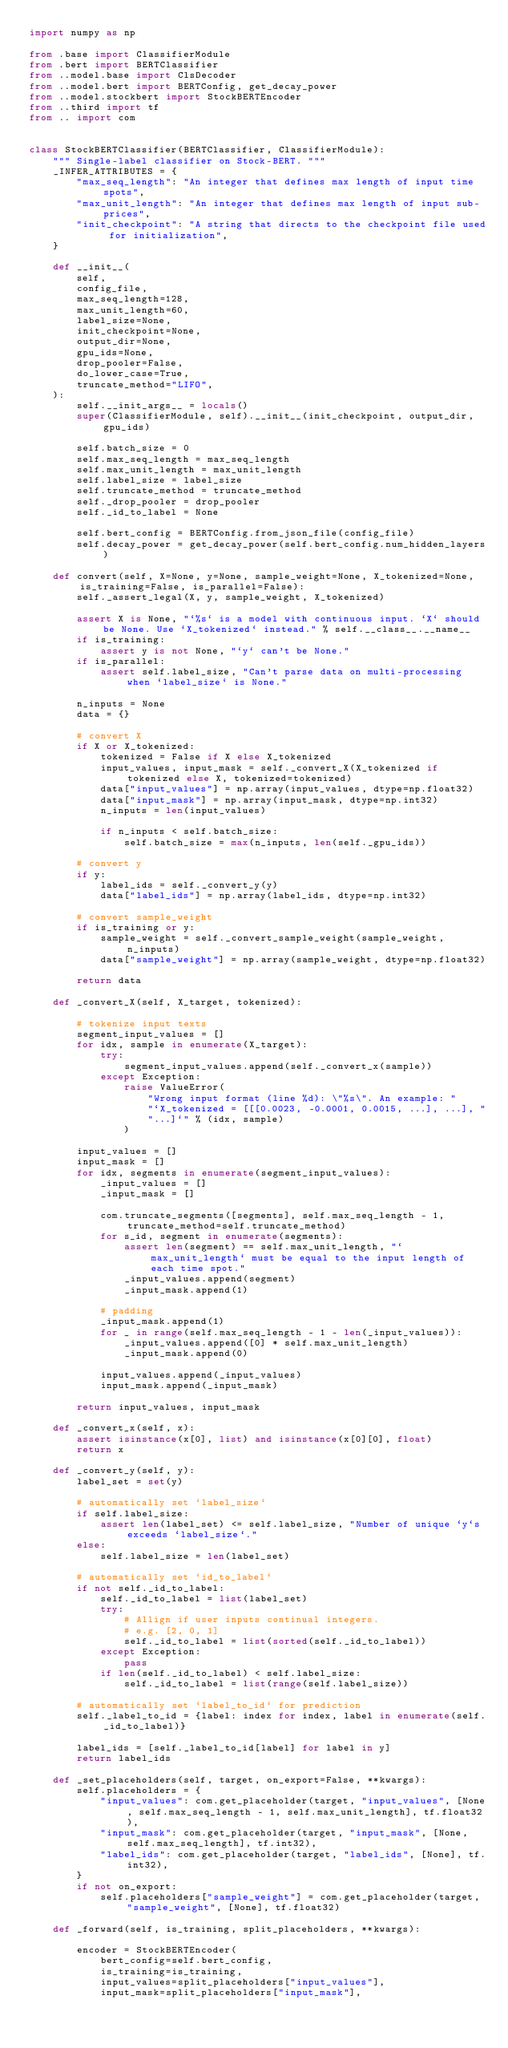<code> <loc_0><loc_0><loc_500><loc_500><_Python_>import numpy as np

from .base import ClassifierModule
from .bert import BERTClassifier
from ..model.base import ClsDecoder
from ..model.bert import BERTConfig, get_decay_power
from ..model.stockbert import StockBERTEncoder
from ..third import tf
from .. import com


class StockBERTClassifier(BERTClassifier, ClassifierModule):
    """ Single-label classifier on Stock-BERT. """
    _INFER_ATTRIBUTES = {
        "max_seq_length": "An integer that defines max length of input time spots",
        "max_unit_length": "An integer that defines max length of input sub-prices",
        "init_checkpoint": "A string that directs to the checkpoint file used for initialization",
    }

    def __init__(
        self,
        config_file,
        max_seq_length=128,
        max_unit_length=60,
        label_size=None,
        init_checkpoint=None,
        output_dir=None,
        gpu_ids=None,
        drop_pooler=False,
        do_lower_case=True,
        truncate_method="LIFO",
    ):
        self.__init_args__ = locals()
        super(ClassifierModule, self).__init__(init_checkpoint, output_dir, gpu_ids)

        self.batch_size = 0
        self.max_seq_length = max_seq_length
        self.max_unit_length = max_unit_length
        self.label_size = label_size
        self.truncate_method = truncate_method
        self._drop_pooler = drop_pooler
        self._id_to_label = None

        self.bert_config = BERTConfig.from_json_file(config_file)
        self.decay_power = get_decay_power(self.bert_config.num_hidden_layers)

    def convert(self, X=None, y=None, sample_weight=None, X_tokenized=None, is_training=False, is_parallel=False):
        self._assert_legal(X, y, sample_weight, X_tokenized)

        assert X is None, "`%s` is a model with continuous input. `X` should be None. Use `X_tokenized` instead." % self.__class__.__name__
        if is_training:
            assert y is not None, "`y` can't be None."
        if is_parallel:
            assert self.label_size, "Can't parse data on multi-processing when `label_size` is None."

        n_inputs = None
        data = {}

        # convert X
        if X or X_tokenized:
            tokenized = False if X else X_tokenized
            input_values, input_mask = self._convert_X(X_tokenized if tokenized else X, tokenized=tokenized)
            data["input_values"] = np.array(input_values, dtype=np.float32)
            data["input_mask"] = np.array(input_mask, dtype=np.int32)
            n_inputs = len(input_values)

            if n_inputs < self.batch_size:
                self.batch_size = max(n_inputs, len(self._gpu_ids))

        # convert y
        if y:
            label_ids = self._convert_y(y)
            data["label_ids"] = np.array(label_ids, dtype=np.int32)

        # convert sample_weight
        if is_training or y:
            sample_weight = self._convert_sample_weight(sample_weight, n_inputs)
            data["sample_weight"] = np.array(sample_weight, dtype=np.float32)

        return data

    def _convert_X(self, X_target, tokenized):

        # tokenize input texts
        segment_input_values = []
        for idx, sample in enumerate(X_target):
            try:
                segment_input_values.append(self._convert_x(sample))
            except Exception:
                raise ValueError(
                    "Wrong input format (line %d): \"%s\". An example: "
                    "`X_tokenized = [[[0.0023, -0.0001, 0.0015, ...], ...], "
                    "...]`" % (idx, sample)
                )

        input_values = []
        input_mask = []
        for idx, segments in enumerate(segment_input_values):
            _input_values = []
            _input_mask = []

            com.truncate_segments([segments], self.max_seq_length - 1, truncate_method=self.truncate_method)
            for s_id, segment in enumerate(segments):
                assert len(segment) == self.max_unit_length, "`max_unit_length` must be equal to the input length of each time spot."
                _input_values.append(segment)
                _input_mask.append(1)

            # padding
            _input_mask.append(1)
            for _ in range(self.max_seq_length - 1 - len(_input_values)):
                _input_values.append([0] * self.max_unit_length)
                _input_mask.append(0)

            input_values.append(_input_values)
            input_mask.append(_input_mask)

        return input_values, input_mask

    def _convert_x(self, x):
        assert isinstance(x[0], list) and isinstance(x[0][0], float)
        return x

    def _convert_y(self, y):
        label_set = set(y)

        # automatically set `label_size`
        if self.label_size:
            assert len(label_set) <= self.label_size, "Number of unique `y`s exceeds `label_size`."
        else:
            self.label_size = len(label_set)

        # automatically set `id_to_label`
        if not self._id_to_label:
            self._id_to_label = list(label_set)
            try:
                # Allign if user inputs continual integers.
                # e.g. [2, 0, 1]
                self._id_to_label = list(sorted(self._id_to_label))
            except Exception:
                pass
            if len(self._id_to_label) < self.label_size:
                self._id_to_label = list(range(self.label_size))

        # automatically set `label_to_id` for prediction
        self._label_to_id = {label: index for index, label in enumerate(self._id_to_label)}

        label_ids = [self._label_to_id[label] for label in y]
        return label_ids

    def _set_placeholders(self, target, on_export=False, **kwargs):
        self.placeholders = {
            "input_values": com.get_placeholder(target, "input_values", [None, self.max_seq_length - 1, self.max_unit_length], tf.float32),
            "input_mask": com.get_placeholder(target, "input_mask", [None, self.max_seq_length], tf.int32),
            "label_ids": com.get_placeholder(target, "label_ids", [None], tf.int32),
        }
        if not on_export:
            self.placeholders["sample_weight"] = com.get_placeholder(target, "sample_weight", [None], tf.float32)

    def _forward(self, is_training, split_placeholders, **kwargs):

        encoder = StockBERTEncoder(
            bert_config=self.bert_config,
            is_training=is_training,
            input_values=split_placeholders["input_values"],
            input_mask=split_placeholders["input_mask"],</code> 